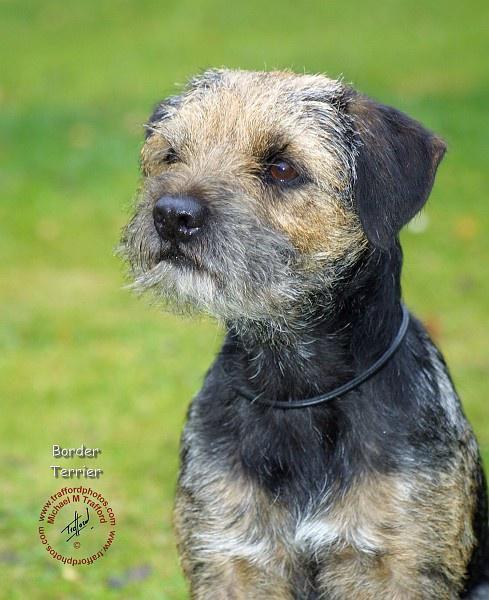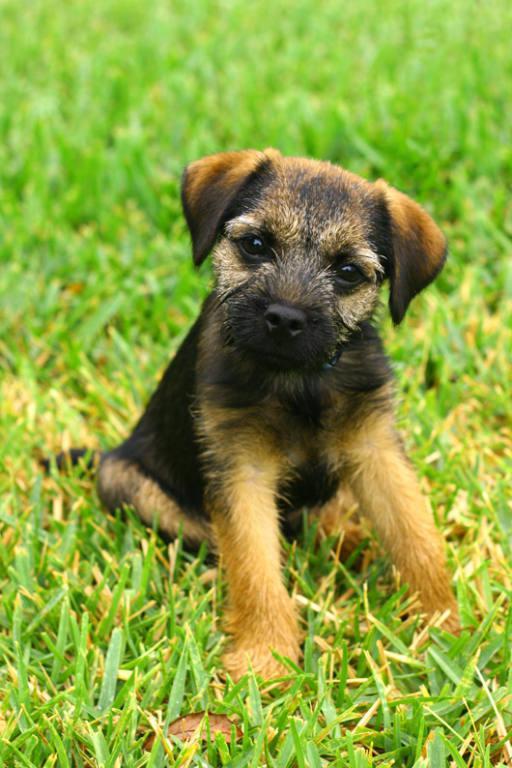The first image is the image on the left, the second image is the image on the right. Assess this claim about the two images: "A dog is looking directly at the camera in both images.". Correct or not? Answer yes or no. No. 